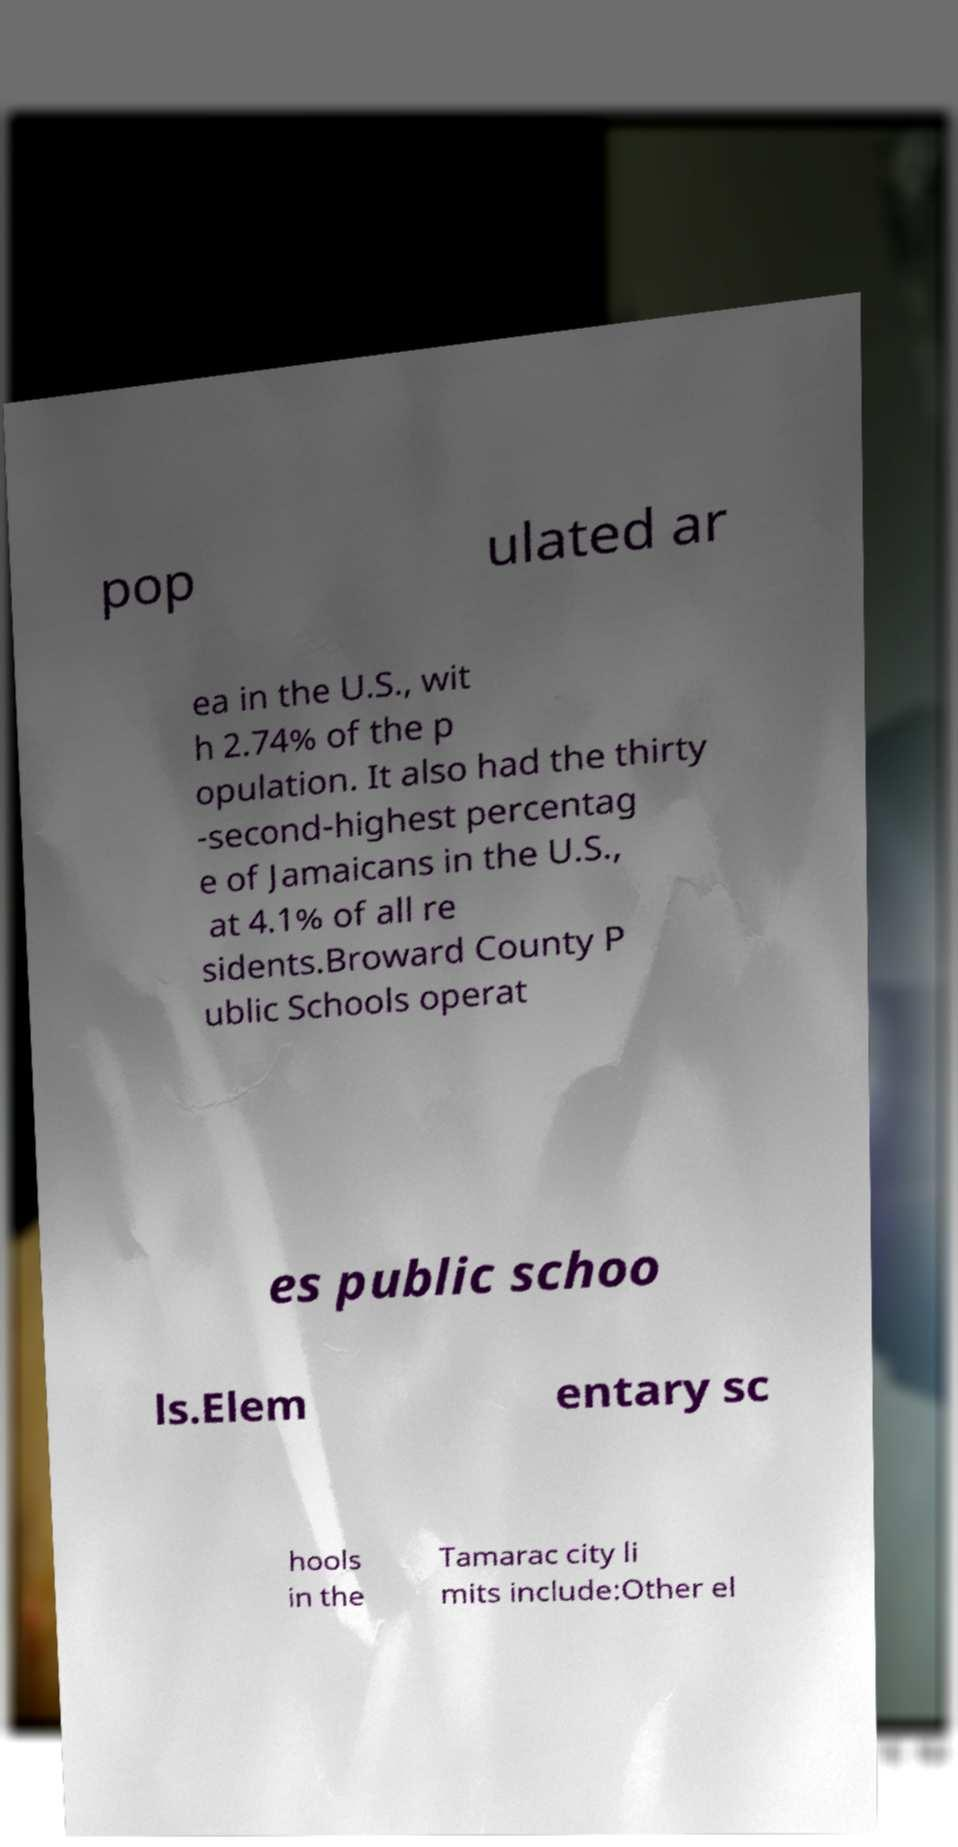I need the written content from this picture converted into text. Can you do that? pop ulated ar ea in the U.S., wit h 2.74% of the p opulation. It also had the thirty -second-highest percentag e of Jamaicans in the U.S., at 4.1% of all re sidents.Broward County P ublic Schools operat es public schoo ls.Elem entary sc hools in the Tamarac city li mits include:Other el 